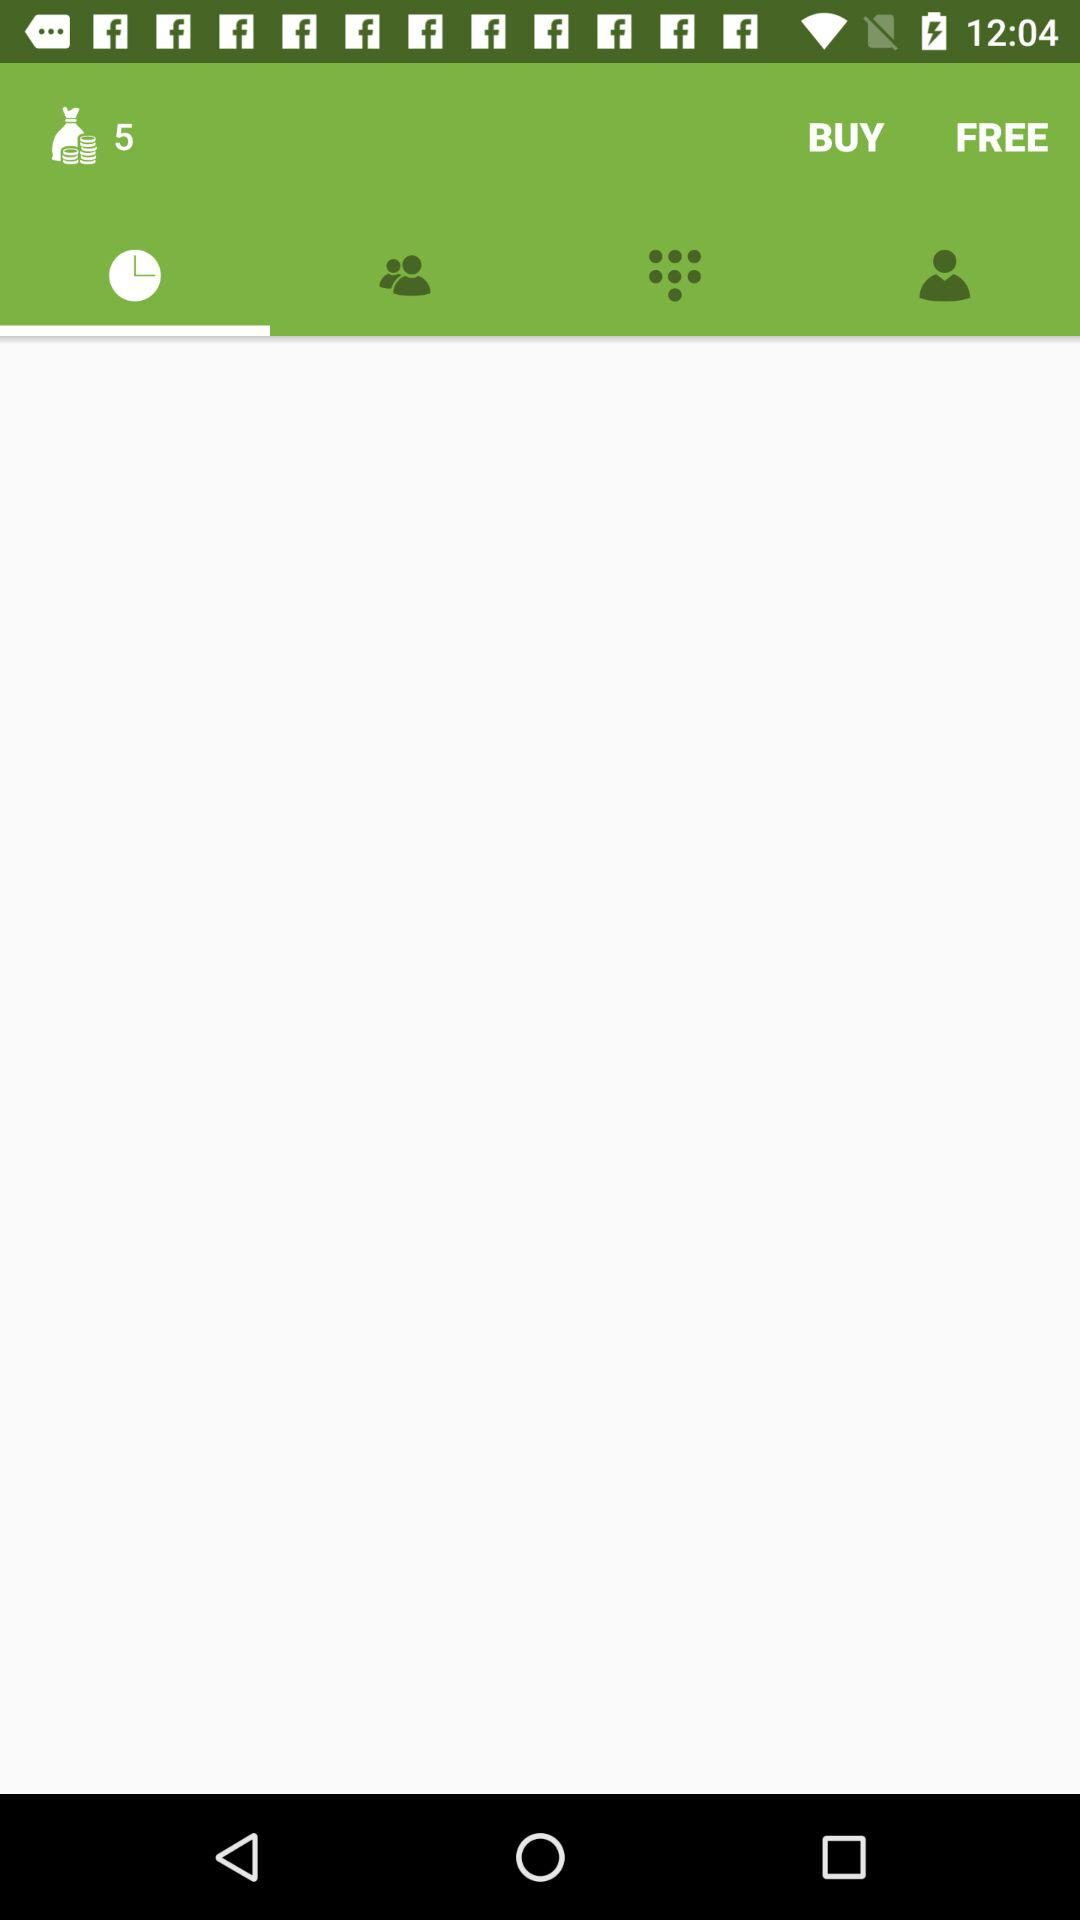What is the number of coins shown in the application? The number of coins shown in the application is 5. 